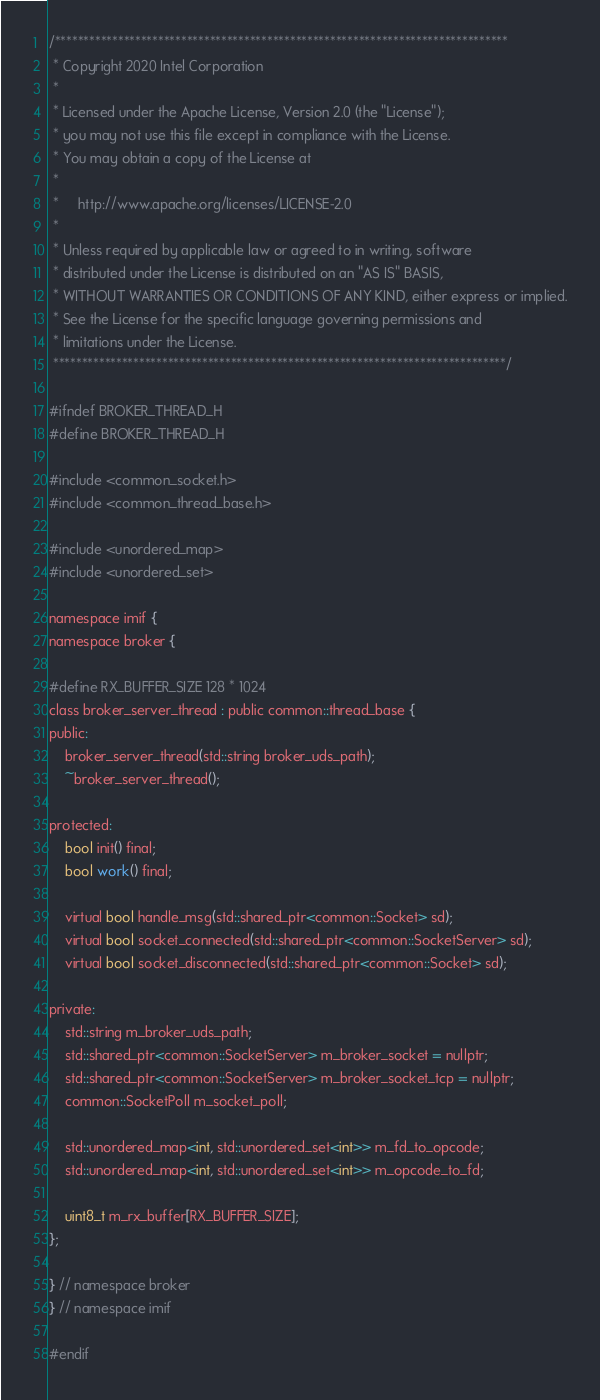<code> <loc_0><loc_0><loc_500><loc_500><_C_>
/*******************************************************************************
 * Copyright 2020 Intel Corporation
 *
 * Licensed under the Apache License, Version 2.0 (the "License");
 * you may not use this file except in compliance with the License.
 * You may obtain a copy of the License at
 *
 *     http://www.apache.org/licenses/LICENSE-2.0
 *
 * Unless required by applicable law or agreed to in writing, software
 * distributed under the License is distributed on an "AS IS" BASIS,
 * WITHOUT WARRANTIES OR CONDITIONS OF ANY KIND, either express or implied.
 * See the License for the specific language governing permissions and
 * limitations under the License.
 *******************************************************************************/

#ifndef BROKER_THREAD_H
#define BROKER_THREAD_H

#include <common_socket.h>
#include <common_thread_base.h>

#include <unordered_map>
#include <unordered_set>

namespace imif {
namespace broker {

#define RX_BUFFER_SIZE 128 * 1024
class broker_server_thread : public common::thread_base {
public:
    broker_server_thread(std::string broker_uds_path);
    ~broker_server_thread();

protected:
    bool init() final;
    bool work() final;

    virtual bool handle_msg(std::shared_ptr<common::Socket> sd);
    virtual bool socket_connected(std::shared_ptr<common::SocketServer> sd);
    virtual bool socket_disconnected(std::shared_ptr<common::Socket> sd);

private:
    std::string m_broker_uds_path;
    std::shared_ptr<common::SocketServer> m_broker_socket = nullptr;
    std::shared_ptr<common::SocketServer> m_broker_socket_tcp = nullptr;
    common::SocketPoll m_socket_poll;

    std::unordered_map<int, std::unordered_set<int>> m_fd_to_opcode;
    std::unordered_map<int, std::unordered_set<int>> m_opcode_to_fd;

    uint8_t m_rx_buffer[RX_BUFFER_SIZE];
};

} // namespace broker
} // namespace imif

#endif
</code> 